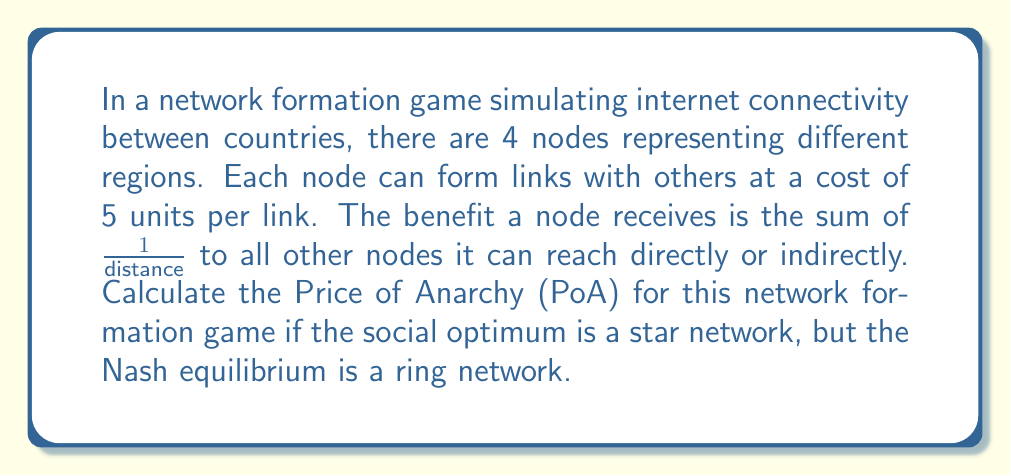Can you answer this question? To solve this problem, we need to follow these steps:

1) Calculate the social welfare of the optimal solution (star network)
2) Calculate the social welfare of the Nash equilibrium (ring network)
3) Compute the Price of Anarchy

Step 1: Social welfare of the star network

In a star network with 4 nodes, there are 3 links. The center node is directly connected to all others, while the outer nodes are indirectly connected to each other through the center.

Cost: $3 * 5 = 15$ units

Benefits:
- Center node: $3 * 1 = 3$
- Each outer node: $1 + 2 * \frac{1}{2} = 2$
- Total benefit: $3 + 3 * 2 = 9$

Social welfare (star) = Benefits - Cost = $9 - 15 = -6$

Step 2: Social welfare of the ring network

In a ring network with 4 nodes, there are 4 links. Each node is directly connected to 2 others and indirectly to 1.

Cost: $4 * 5 = 20$ units

Benefits for each node: $2 * 1 + \frac{1}{2} = 2.5$
Total benefit: $4 * 2.5 = 10$

Social welfare (ring) = Benefits - Cost = $10 - 20 = -10$

Step 3: Price of Anarchy

The Price of Anarchy is defined as:

$$ PoA = \frac{\text{Social Welfare of Optimal Solution}}{\text{Social Welfare of Nash Equilibrium}} $$

Substituting our values:

$$ PoA = \frac{-6}{-10} = 0.6 $$
Answer: The Price of Anarchy (PoA) for this network formation game is 0.6. 